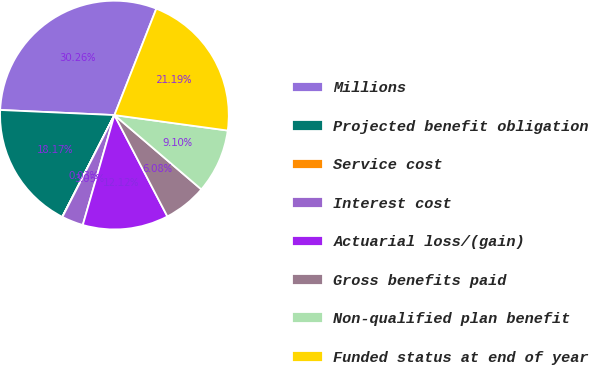Convert chart to OTSL. <chart><loc_0><loc_0><loc_500><loc_500><pie_chart><fcel>Millions<fcel>Projected benefit obligation<fcel>Service cost<fcel>Interest cost<fcel>Actuarial loss/(gain)<fcel>Gross benefits paid<fcel>Non-qualified plan benefit<fcel>Funded status at end of year<nl><fcel>30.26%<fcel>18.17%<fcel>0.03%<fcel>3.05%<fcel>12.12%<fcel>6.08%<fcel>9.1%<fcel>21.19%<nl></chart> 